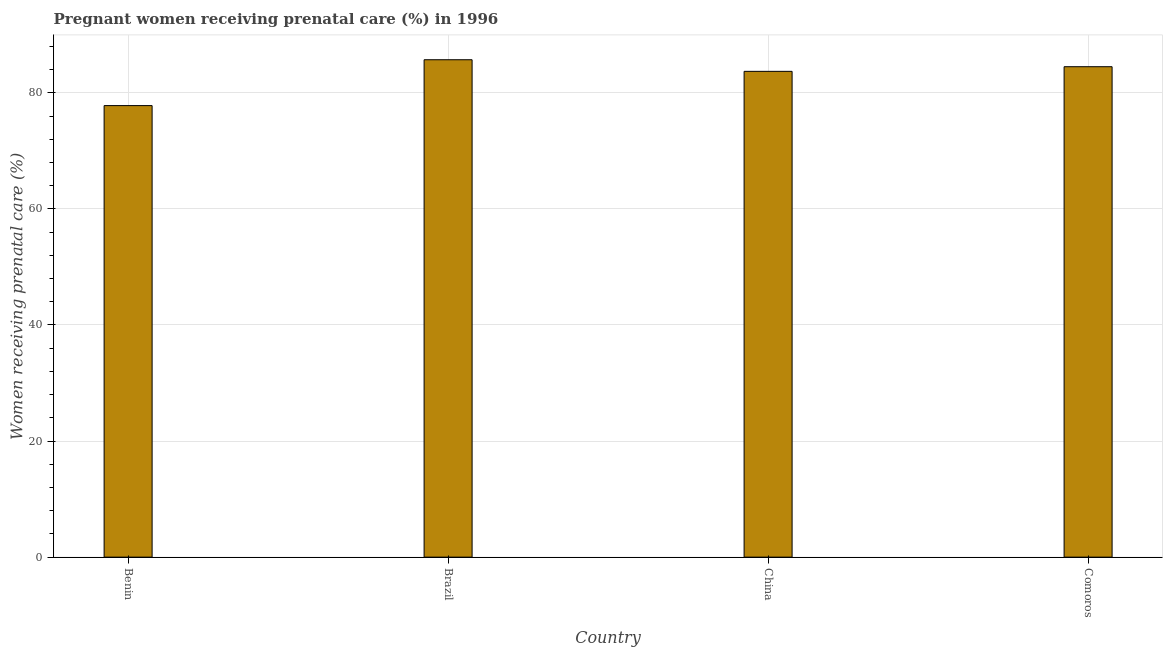Does the graph contain grids?
Provide a succinct answer. Yes. What is the title of the graph?
Make the answer very short. Pregnant women receiving prenatal care (%) in 1996. What is the label or title of the Y-axis?
Offer a terse response. Women receiving prenatal care (%). What is the percentage of pregnant women receiving prenatal care in Comoros?
Your response must be concise. 84.5. Across all countries, what is the maximum percentage of pregnant women receiving prenatal care?
Provide a short and direct response. 85.7. Across all countries, what is the minimum percentage of pregnant women receiving prenatal care?
Provide a short and direct response. 77.8. In which country was the percentage of pregnant women receiving prenatal care maximum?
Your answer should be very brief. Brazil. In which country was the percentage of pregnant women receiving prenatal care minimum?
Make the answer very short. Benin. What is the sum of the percentage of pregnant women receiving prenatal care?
Keep it short and to the point. 331.7. What is the average percentage of pregnant women receiving prenatal care per country?
Give a very brief answer. 82.92. What is the median percentage of pregnant women receiving prenatal care?
Provide a short and direct response. 84.1. In how many countries, is the percentage of pregnant women receiving prenatal care greater than 40 %?
Your answer should be very brief. 4. What is the ratio of the percentage of pregnant women receiving prenatal care in Benin to that in Comoros?
Your response must be concise. 0.92. Is the difference between the percentage of pregnant women receiving prenatal care in China and Comoros greater than the difference between any two countries?
Offer a terse response. No. What is the difference between the highest and the second highest percentage of pregnant women receiving prenatal care?
Your response must be concise. 1.2. Is the sum of the percentage of pregnant women receiving prenatal care in Brazil and China greater than the maximum percentage of pregnant women receiving prenatal care across all countries?
Your answer should be compact. Yes. Are all the bars in the graph horizontal?
Offer a very short reply. No. How many countries are there in the graph?
Keep it short and to the point. 4. Are the values on the major ticks of Y-axis written in scientific E-notation?
Your answer should be very brief. No. What is the Women receiving prenatal care (%) in Benin?
Provide a succinct answer. 77.8. What is the Women receiving prenatal care (%) of Brazil?
Keep it short and to the point. 85.7. What is the Women receiving prenatal care (%) in China?
Offer a terse response. 83.7. What is the Women receiving prenatal care (%) of Comoros?
Provide a succinct answer. 84.5. What is the difference between the Women receiving prenatal care (%) in Benin and Brazil?
Offer a very short reply. -7.9. What is the difference between the Women receiving prenatal care (%) in China and Comoros?
Your answer should be compact. -0.8. What is the ratio of the Women receiving prenatal care (%) in Benin to that in Brazil?
Offer a very short reply. 0.91. What is the ratio of the Women receiving prenatal care (%) in Benin to that in China?
Offer a very short reply. 0.93. What is the ratio of the Women receiving prenatal care (%) in Benin to that in Comoros?
Offer a very short reply. 0.92. 